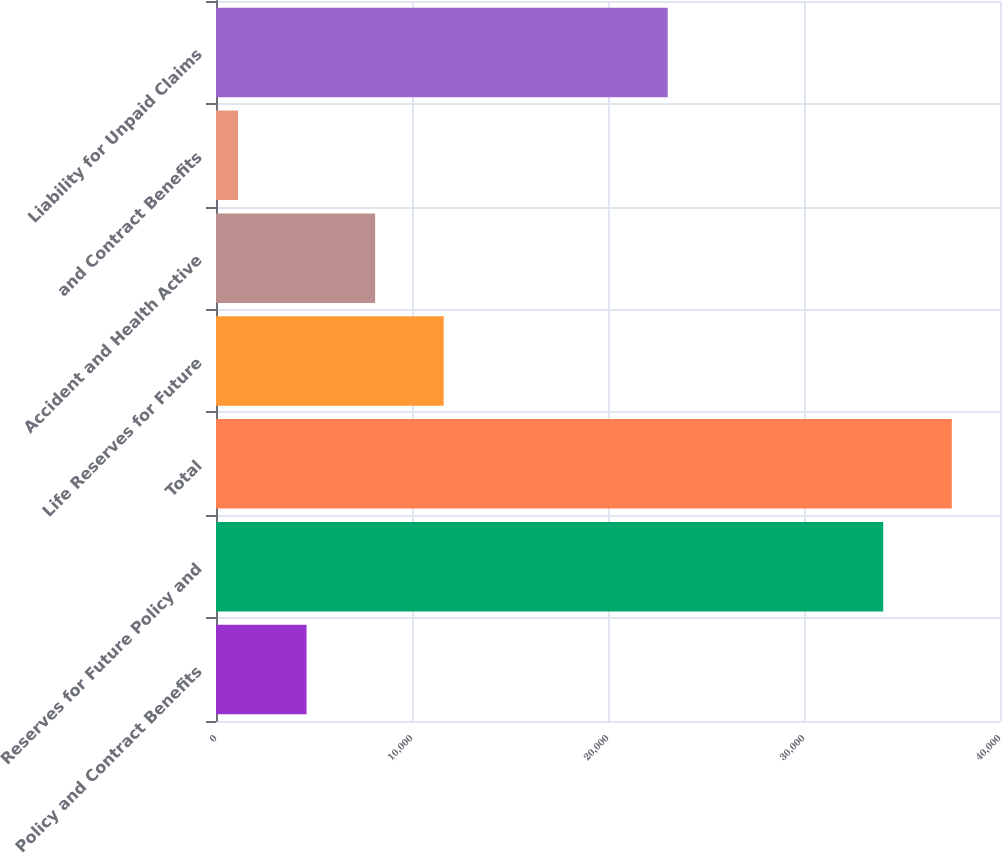Convert chart. <chart><loc_0><loc_0><loc_500><loc_500><bar_chart><fcel>Policy and Contract Benefits<fcel>Reserves for Future Policy and<fcel>Total<fcel>Life Reserves for Future<fcel>Accident and Health Active<fcel>and Contract Benefits<fcel>Liability for Unpaid Claims<nl><fcel>4619.66<fcel>34041.5<fcel>37539.9<fcel>11616.4<fcel>8118.02<fcel>1121.3<fcel>23047.7<nl></chart> 